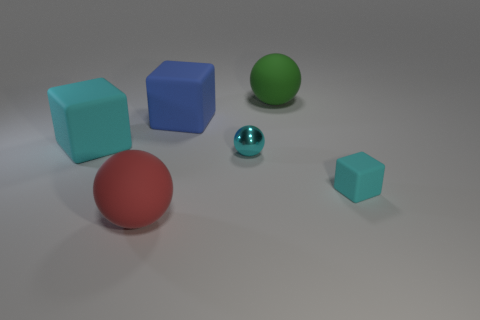Subtract all cyan matte blocks. How many blocks are left? 1 Subtract all cyan balls. How many cyan blocks are left? 2 Add 1 tiny cyan metallic spheres. How many objects exist? 7 Subtract all red blocks. Subtract all purple cylinders. How many blocks are left? 3 Add 4 balls. How many balls exist? 7 Subtract 0 gray cubes. How many objects are left? 6 Subtract all matte things. Subtract all large blue things. How many objects are left? 0 Add 2 blue blocks. How many blue blocks are left? 3 